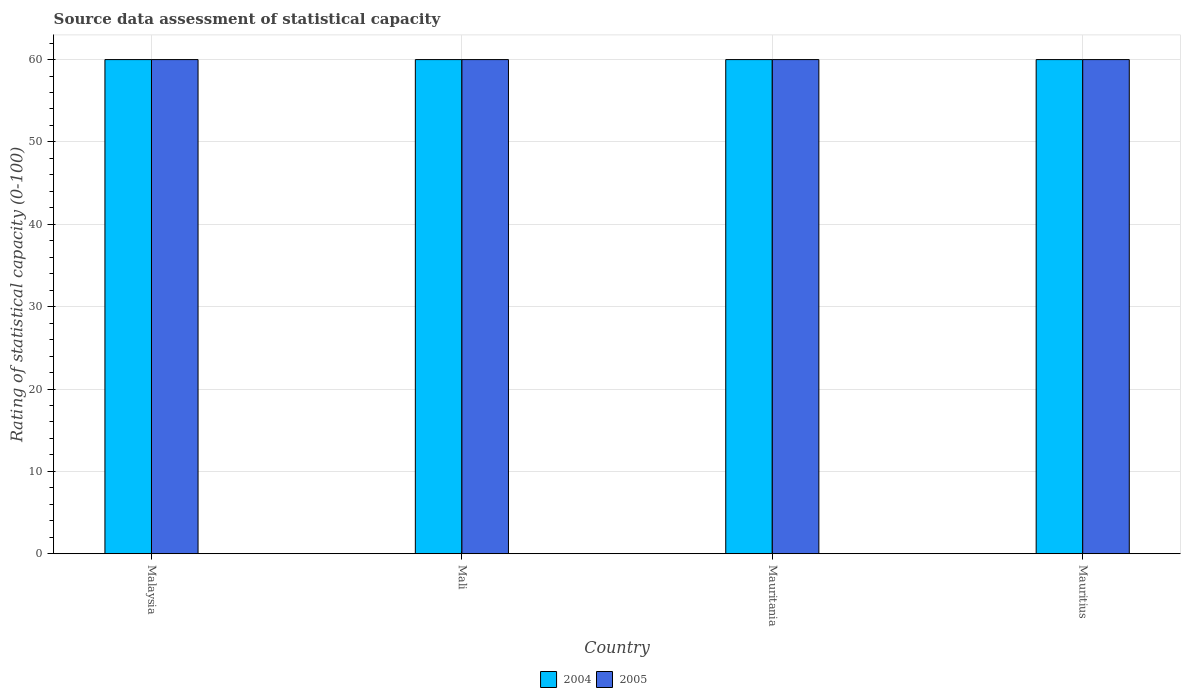How many different coloured bars are there?
Your answer should be compact. 2. Are the number of bars per tick equal to the number of legend labels?
Offer a very short reply. Yes. Are the number of bars on each tick of the X-axis equal?
Offer a very short reply. Yes. How many bars are there on the 2nd tick from the right?
Offer a terse response. 2. What is the label of the 3rd group of bars from the left?
Keep it short and to the point. Mauritania. Across all countries, what is the maximum rating of statistical capacity in 2005?
Your response must be concise. 60. Across all countries, what is the minimum rating of statistical capacity in 2005?
Provide a short and direct response. 60. In which country was the rating of statistical capacity in 2004 maximum?
Ensure brevity in your answer.  Malaysia. In which country was the rating of statistical capacity in 2004 minimum?
Ensure brevity in your answer.  Malaysia. What is the total rating of statistical capacity in 2004 in the graph?
Give a very brief answer. 240. What is the difference between the rating of statistical capacity of/in 2005 and rating of statistical capacity of/in 2004 in Mauritius?
Make the answer very short. 0. Is the difference between the rating of statistical capacity in 2005 in Malaysia and Mauritius greater than the difference between the rating of statistical capacity in 2004 in Malaysia and Mauritius?
Offer a very short reply. No. What is the difference between the highest and the lowest rating of statistical capacity in 2005?
Offer a very short reply. 0. Are all the bars in the graph horizontal?
Keep it short and to the point. No. What is the difference between two consecutive major ticks on the Y-axis?
Keep it short and to the point. 10. Does the graph contain any zero values?
Ensure brevity in your answer.  No. Does the graph contain grids?
Provide a short and direct response. Yes. How many legend labels are there?
Your answer should be very brief. 2. What is the title of the graph?
Your answer should be very brief. Source data assessment of statistical capacity. Does "1973" appear as one of the legend labels in the graph?
Your answer should be very brief. No. What is the label or title of the X-axis?
Make the answer very short. Country. What is the label or title of the Y-axis?
Provide a succinct answer. Rating of statistical capacity (0-100). What is the Rating of statistical capacity (0-100) of 2005 in Mali?
Make the answer very short. 60. What is the Rating of statistical capacity (0-100) in 2005 in Mauritius?
Provide a succinct answer. 60. Across all countries, what is the maximum Rating of statistical capacity (0-100) in 2005?
Ensure brevity in your answer.  60. Across all countries, what is the minimum Rating of statistical capacity (0-100) of 2005?
Your answer should be compact. 60. What is the total Rating of statistical capacity (0-100) in 2004 in the graph?
Offer a terse response. 240. What is the total Rating of statistical capacity (0-100) of 2005 in the graph?
Provide a short and direct response. 240. What is the difference between the Rating of statistical capacity (0-100) in 2004 in Malaysia and that in Mali?
Ensure brevity in your answer.  0. What is the difference between the Rating of statistical capacity (0-100) of 2004 in Malaysia and that in Mauritania?
Provide a short and direct response. 0. What is the difference between the Rating of statistical capacity (0-100) of 2005 in Malaysia and that in Mauritius?
Offer a terse response. 0. What is the difference between the Rating of statistical capacity (0-100) in 2005 in Mali and that in Mauritania?
Offer a terse response. 0. What is the difference between the Rating of statistical capacity (0-100) in 2004 in Mali and that in Mauritius?
Your answer should be compact. 0. What is the difference between the Rating of statistical capacity (0-100) in 2005 in Mali and that in Mauritius?
Keep it short and to the point. 0. What is the difference between the Rating of statistical capacity (0-100) in 2004 in Mauritania and that in Mauritius?
Provide a succinct answer. 0. What is the difference between the Rating of statistical capacity (0-100) in 2005 in Mauritania and that in Mauritius?
Ensure brevity in your answer.  0. What is the difference between the Rating of statistical capacity (0-100) of 2004 in Malaysia and the Rating of statistical capacity (0-100) of 2005 in Mauritania?
Provide a succinct answer. 0. What is the difference between the Rating of statistical capacity (0-100) of 2004 in Malaysia and the Rating of statistical capacity (0-100) of 2005 in Mauritius?
Offer a very short reply. 0. What is the difference between the Rating of statistical capacity (0-100) in 2004 in Mali and the Rating of statistical capacity (0-100) in 2005 in Mauritania?
Keep it short and to the point. 0. What is the average Rating of statistical capacity (0-100) in 2004 per country?
Make the answer very short. 60. What is the difference between the Rating of statistical capacity (0-100) in 2004 and Rating of statistical capacity (0-100) in 2005 in Malaysia?
Your response must be concise. 0. What is the difference between the Rating of statistical capacity (0-100) in 2004 and Rating of statistical capacity (0-100) in 2005 in Mauritania?
Make the answer very short. 0. What is the difference between the Rating of statistical capacity (0-100) of 2004 and Rating of statistical capacity (0-100) of 2005 in Mauritius?
Ensure brevity in your answer.  0. What is the ratio of the Rating of statistical capacity (0-100) in 2004 in Malaysia to that in Mali?
Offer a terse response. 1. What is the ratio of the Rating of statistical capacity (0-100) of 2004 in Malaysia to that in Mauritania?
Your answer should be compact. 1. What is the ratio of the Rating of statistical capacity (0-100) of 2004 in Malaysia to that in Mauritius?
Ensure brevity in your answer.  1. What is the ratio of the Rating of statistical capacity (0-100) of 2004 in Mali to that in Mauritania?
Offer a very short reply. 1. What is the ratio of the Rating of statistical capacity (0-100) in 2005 in Mali to that in Mauritius?
Provide a succinct answer. 1. What is the ratio of the Rating of statistical capacity (0-100) of 2005 in Mauritania to that in Mauritius?
Your answer should be compact. 1. 